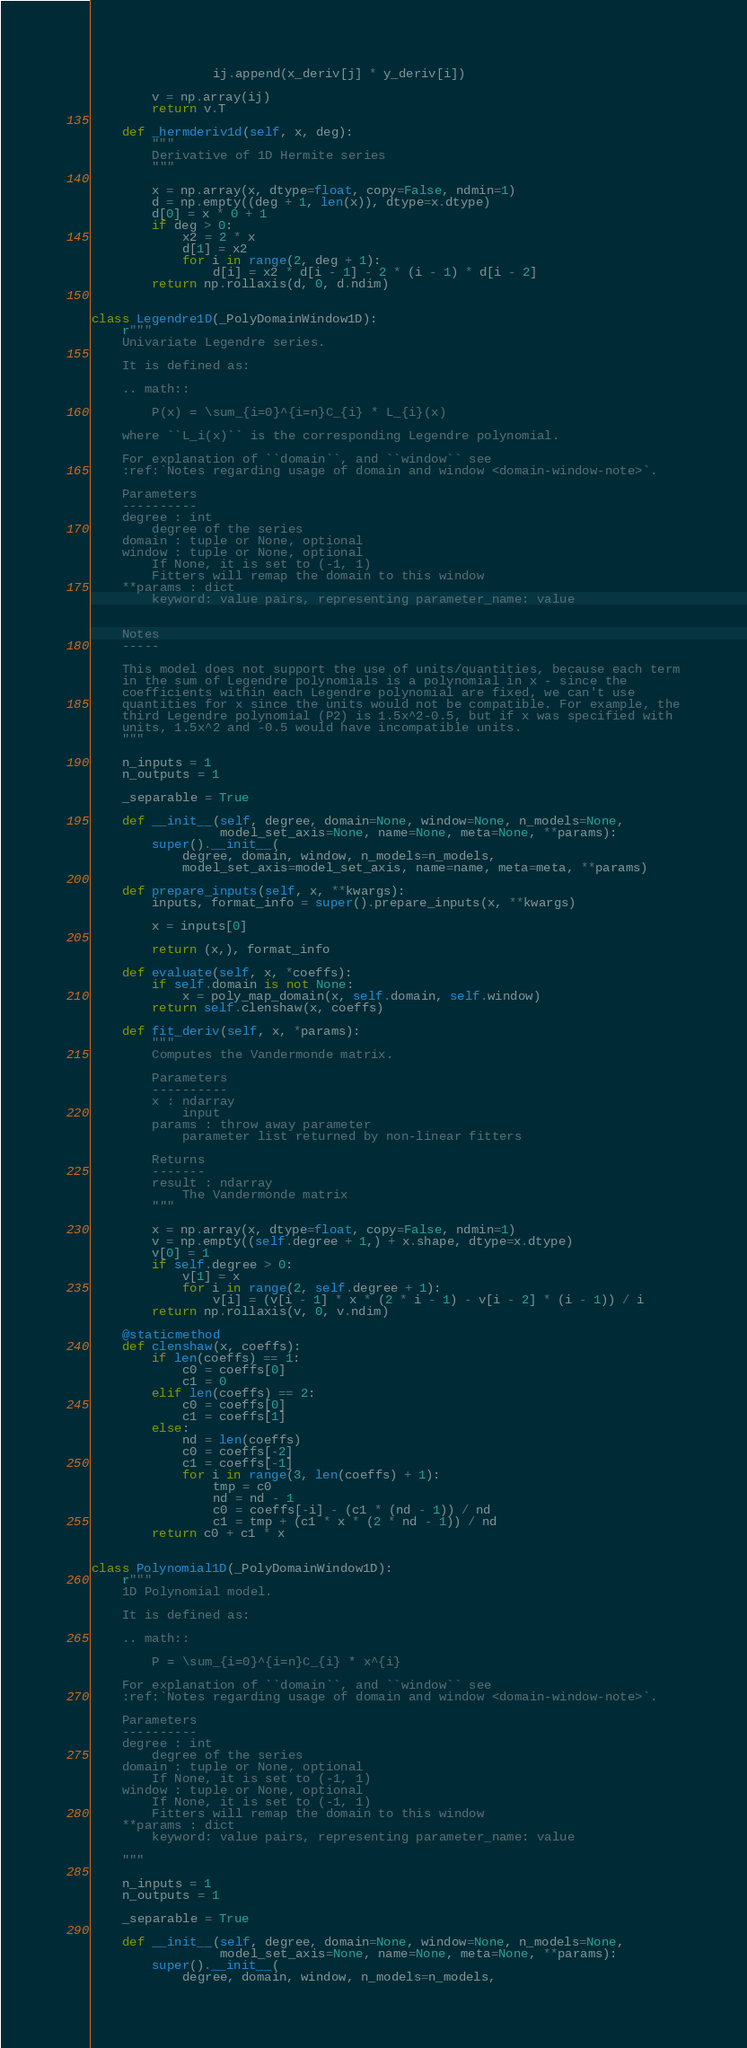Convert code to text. <code><loc_0><loc_0><loc_500><loc_500><_Python_>                ij.append(x_deriv[j] * y_deriv[i])

        v = np.array(ij)
        return v.T

    def _hermderiv1d(self, x, deg):
        """
        Derivative of 1D Hermite series
        """

        x = np.array(x, dtype=float, copy=False, ndmin=1)
        d = np.empty((deg + 1, len(x)), dtype=x.dtype)
        d[0] = x * 0 + 1
        if deg > 0:
            x2 = 2 * x
            d[1] = x2
            for i in range(2, deg + 1):
                d[i] = x2 * d[i - 1] - 2 * (i - 1) * d[i - 2]
        return np.rollaxis(d, 0, d.ndim)


class Legendre1D(_PolyDomainWindow1D):
    r"""
    Univariate Legendre series.

    It is defined as:

    .. math::

        P(x) = \sum_{i=0}^{i=n}C_{i} * L_{i}(x)

    where ``L_i(x)`` is the corresponding Legendre polynomial.

    For explanation of ``domain``, and ``window`` see
    :ref:`Notes regarding usage of domain and window <domain-window-note>`.

    Parameters
    ----------
    degree : int
        degree of the series
    domain : tuple or None, optional
    window : tuple or None, optional
        If None, it is set to (-1, 1)
        Fitters will remap the domain to this window
    **params : dict
        keyword: value pairs, representing parameter_name: value


    Notes
    -----

    This model does not support the use of units/quantities, because each term
    in the sum of Legendre polynomials is a polynomial in x - since the
    coefficients within each Legendre polynomial are fixed, we can't use
    quantities for x since the units would not be compatible. For example, the
    third Legendre polynomial (P2) is 1.5x^2-0.5, but if x was specified with
    units, 1.5x^2 and -0.5 would have incompatible units.
    """

    n_inputs = 1
    n_outputs = 1

    _separable = True

    def __init__(self, degree, domain=None, window=None, n_models=None,
                 model_set_axis=None, name=None, meta=None, **params):
        super().__init__(
            degree, domain, window, n_models=n_models,
            model_set_axis=model_set_axis, name=name, meta=meta, **params)

    def prepare_inputs(self, x, **kwargs):
        inputs, format_info = super().prepare_inputs(x, **kwargs)

        x = inputs[0]

        return (x,), format_info

    def evaluate(self, x, *coeffs):
        if self.domain is not None:
            x = poly_map_domain(x, self.domain, self.window)
        return self.clenshaw(x, coeffs)

    def fit_deriv(self, x, *params):
        """
        Computes the Vandermonde matrix.

        Parameters
        ----------
        x : ndarray
            input
        params : throw away parameter
            parameter list returned by non-linear fitters

        Returns
        -------
        result : ndarray
            The Vandermonde matrix
        """

        x = np.array(x, dtype=float, copy=False, ndmin=1)
        v = np.empty((self.degree + 1,) + x.shape, dtype=x.dtype)
        v[0] = 1
        if self.degree > 0:
            v[1] = x
            for i in range(2, self.degree + 1):
                v[i] = (v[i - 1] * x * (2 * i - 1) - v[i - 2] * (i - 1)) / i
        return np.rollaxis(v, 0, v.ndim)

    @staticmethod
    def clenshaw(x, coeffs):
        if len(coeffs) == 1:
            c0 = coeffs[0]
            c1 = 0
        elif len(coeffs) == 2:
            c0 = coeffs[0]
            c1 = coeffs[1]
        else:
            nd = len(coeffs)
            c0 = coeffs[-2]
            c1 = coeffs[-1]
            for i in range(3, len(coeffs) + 1):
                tmp = c0
                nd = nd - 1
                c0 = coeffs[-i] - (c1 * (nd - 1)) / nd
                c1 = tmp + (c1 * x * (2 * nd - 1)) / nd
        return c0 + c1 * x


class Polynomial1D(_PolyDomainWindow1D):
    r"""
    1D Polynomial model.

    It is defined as:

    .. math::

        P = \sum_{i=0}^{i=n}C_{i} * x^{i}

    For explanation of ``domain``, and ``window`` see
    :ref:`Notes regarding usage of domain and window <domain-window-note>`.

    Parameters
    ----------
    degree : int
        degree of the series
    domain : tuple or None, optional
        If None, it is set to (-1, 1)
    window : tuple or None, optional
        If None, it is set to (-1, 1)
        Fitters will remap the domain to this window
    **params : dict
        keyword: value pairs, representing parameter_name: value

    """

    n_inputs = 1
    n_outputs = 1

    _separable = True

    def __init__(self, degree, domain=None, window=None, n_models=None,
                 model_set_axis=None, name=None, meta=None, **params):
        super().__init__(
            degree, domain, window, n_models=n_models,</code> 